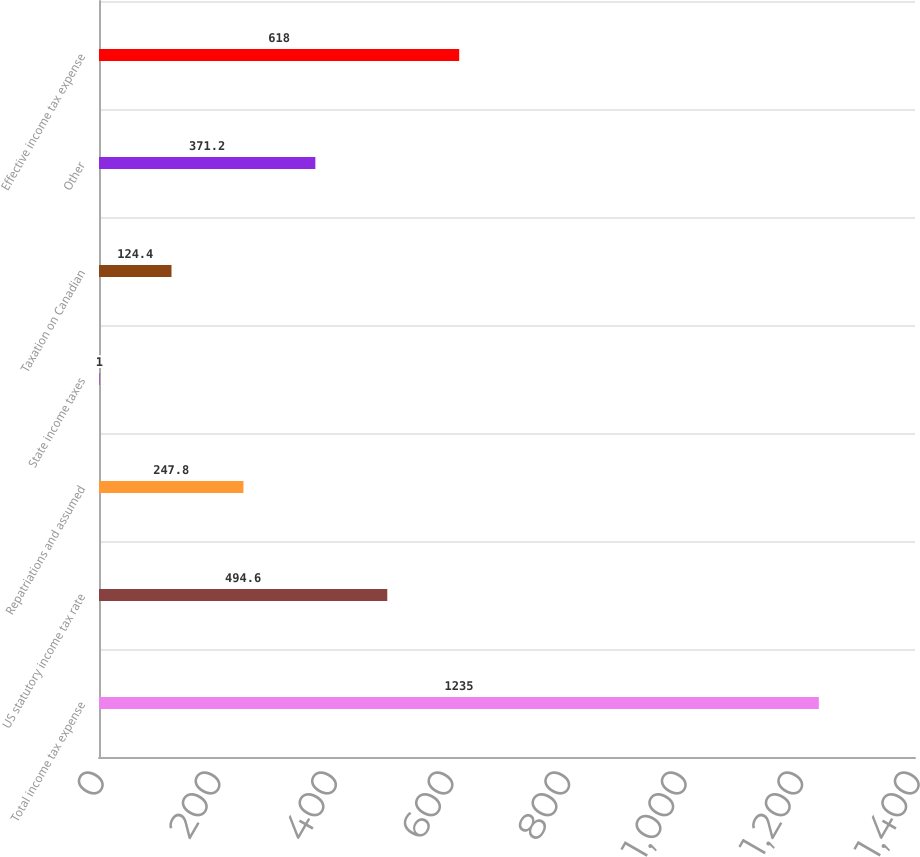<chart> <loc_0><loc_0><loc_500><loc_500><bar_chart><fcel>Total income tax expense<fcel>US statutory income tax rate<fcel>Repatriations and assumed<fcel>State income taxes<fcel>Taxation on Canadian<fcel>Other<fcel>Effective income tax expense<nl><fcel>1235<fcel>494.6<fcel>247.8<fcel>1<fcel>124.4<fcel>371.2<fcel>618<nl></chart> 